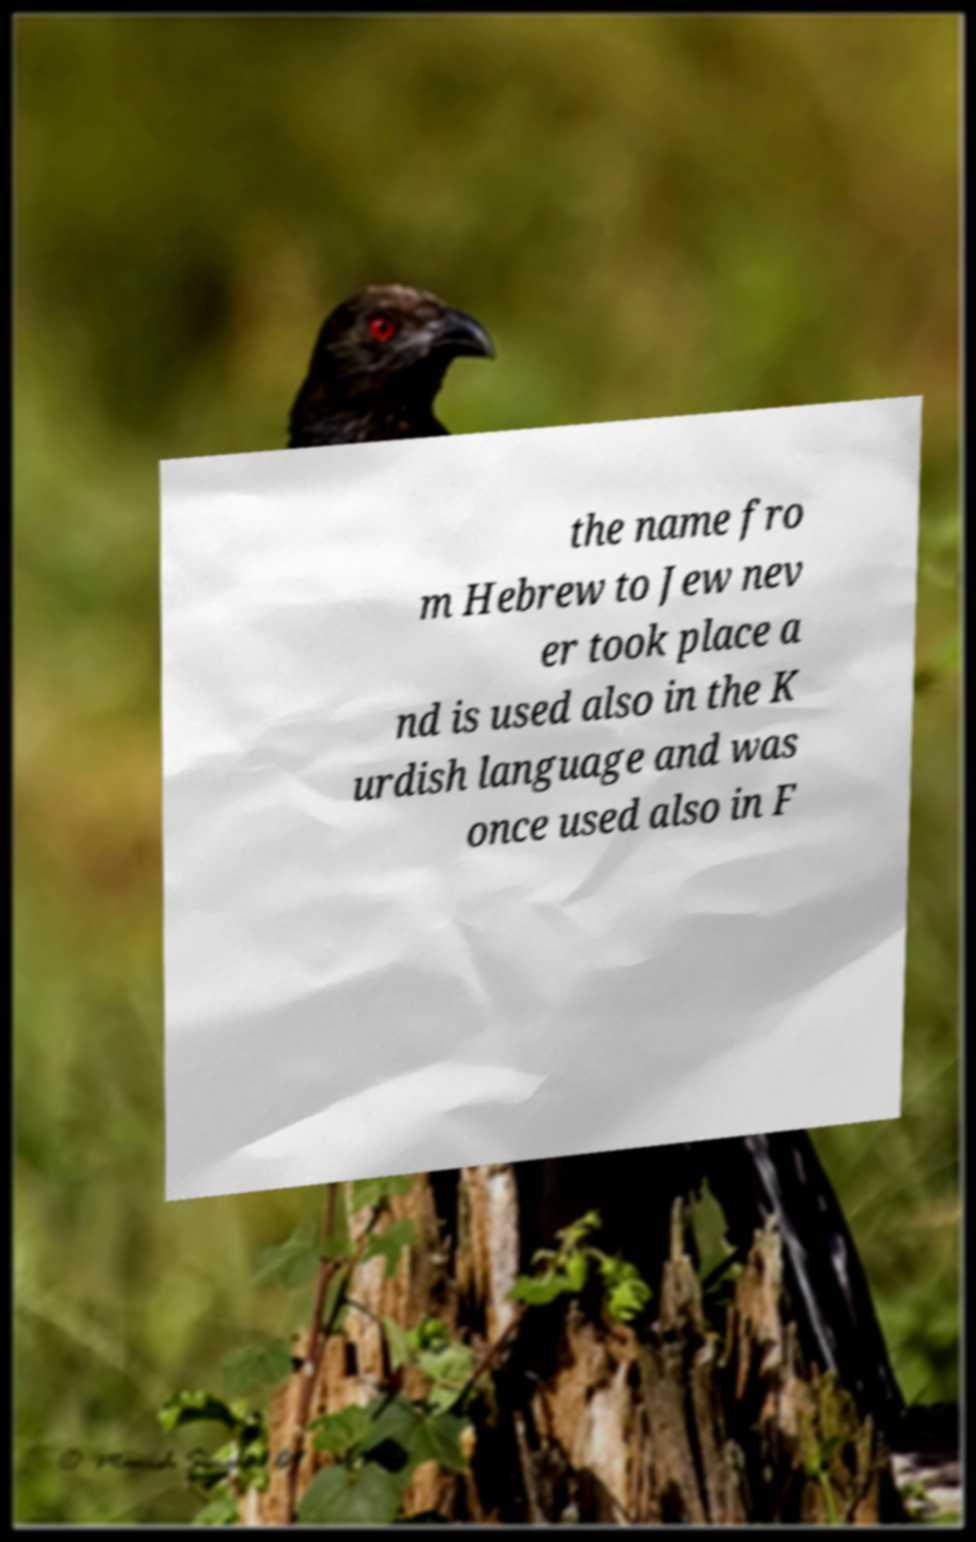I need the written content from this picture converted into text. Can you do that? the name fro m Hebrew to Jew nev er took place a nd is used also in the K urdish language and was once used also in F 